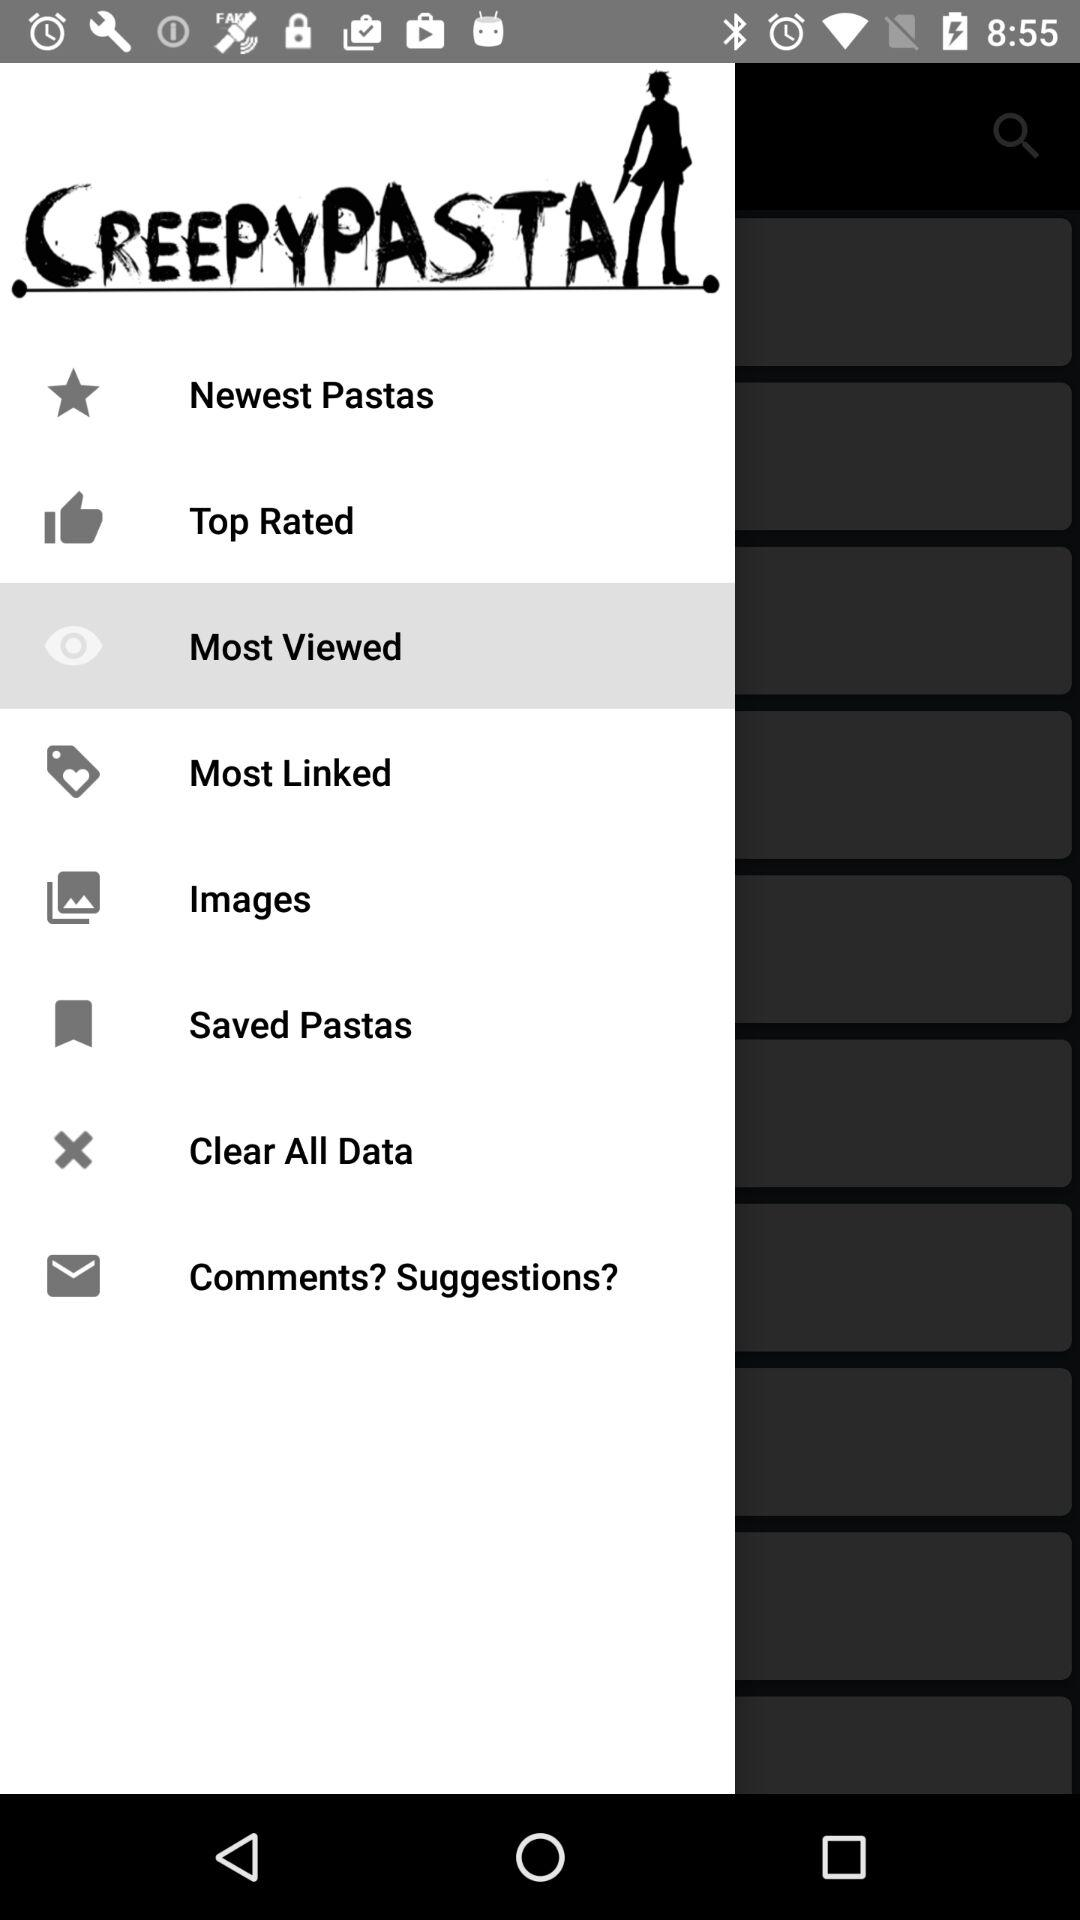What is the application name? The application name is "CREEPYPASTA". 